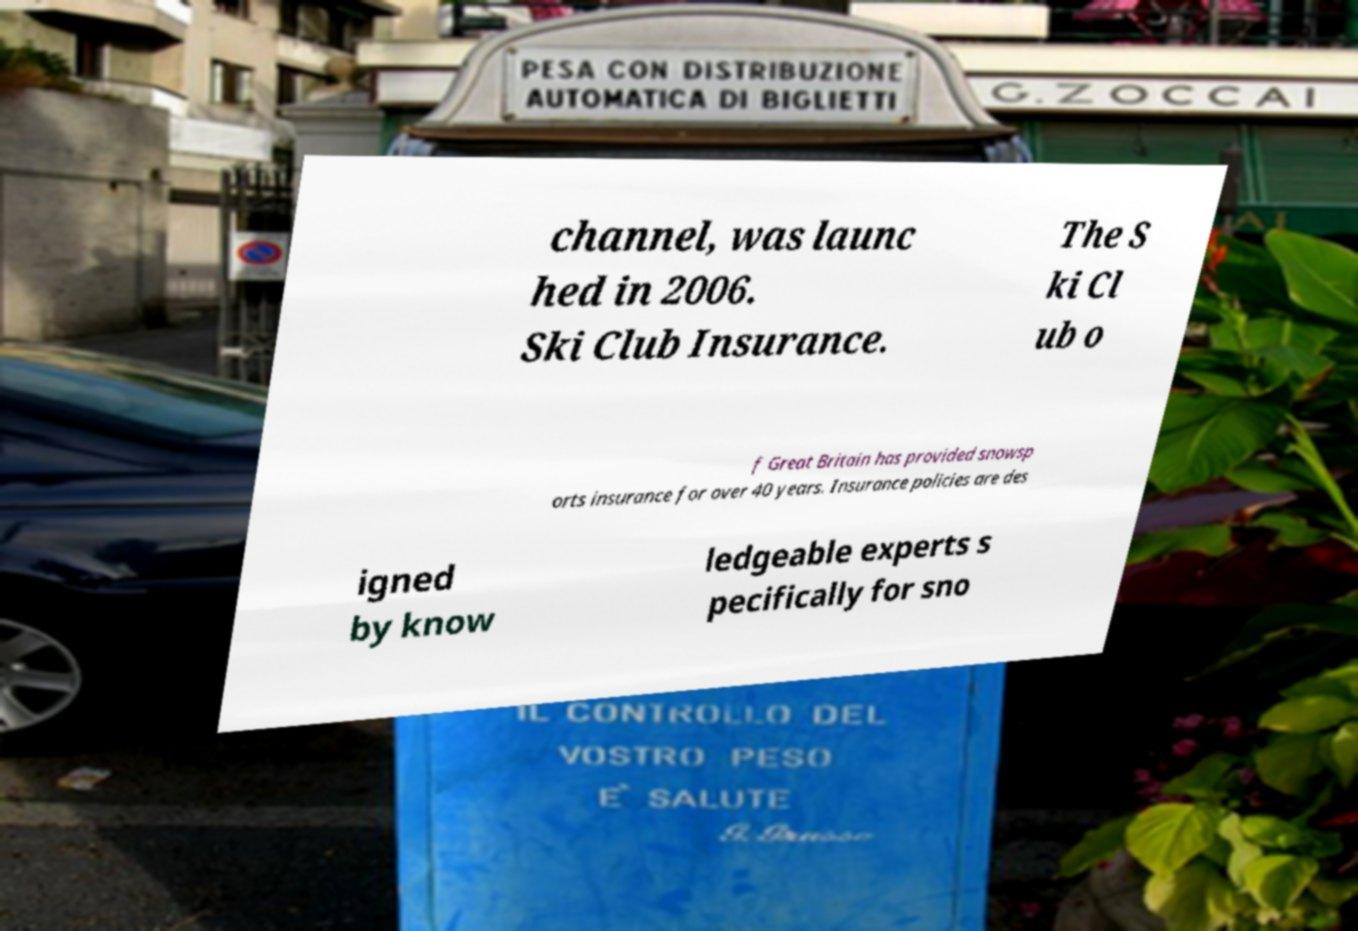I need the written content from this picture converted into text. Can you do that? channel, was launc hed in 2006. Ski Club Insurance. The S ki Cl ub o f Great Britain has provided snowsp orts insurance for over 40 years. Insurance policies are des igned by know ledgeable experts s pecifically for sno 